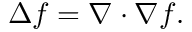Convert formula to latex. <formula><loc_0><loc_0><loc_500><loc_500>\Delta f = \nabla \cdot \nabla f .</formula> 